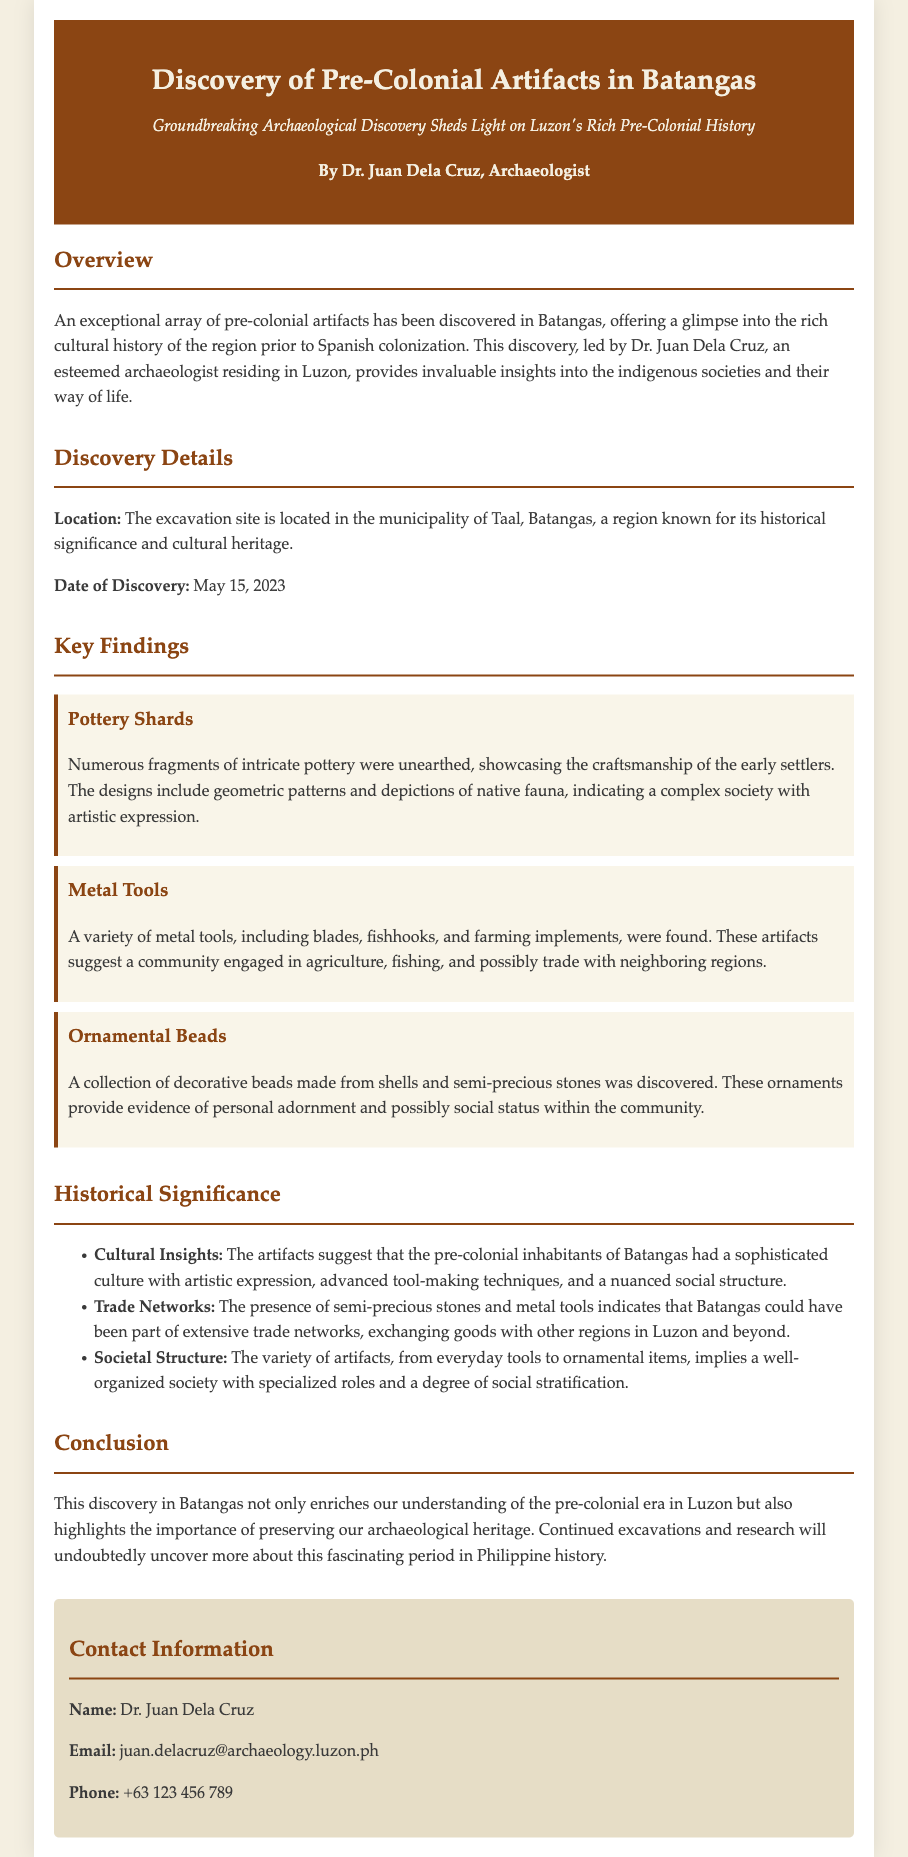What is the location of the excavation site? The excavation site is specifically noted to be in the municipality of Taal, Batangas, according to the discovery details.
Answer: Taal, Batangas Who led the archaeological discovery? The press release states that the discovery was led by Dr. Juan Dela Cruz.
Answer: Dr. Juan Dela Cruz When was the discovery made? The date of the discovery is specifically mentioned in the document as May 15, 2023.
Answer: May 15, 2023 What type of artifacts were primarily discovered? The key findings detail a variety of artifacts including pottery shards, metal tools, and ornamental beads.
Answer: Pottery shards, metal tools, ornamental beads What do the artifacts suggest about the societal structure of the inhabitants? The historical significance section highlights that the artifacts imply a well-organized society with specialized roles and a degree of social stratification.
Answer: Well-organized society with specialized roles What does the presence of semi-precious stones indicate? The document notes that semi-precious stones suggest Batangas may have been part of extensive trade networks with other regions.
Answer: Extensive trade networks What type of document is this? The structure and content of the document confirm it is a press release about an archaeological discovery.
Answer: Press release How many types of artifacts are listed in the key findings? The key findings mention three distinct types of artifacts, which are indicated in the document.
Answer: Three types 